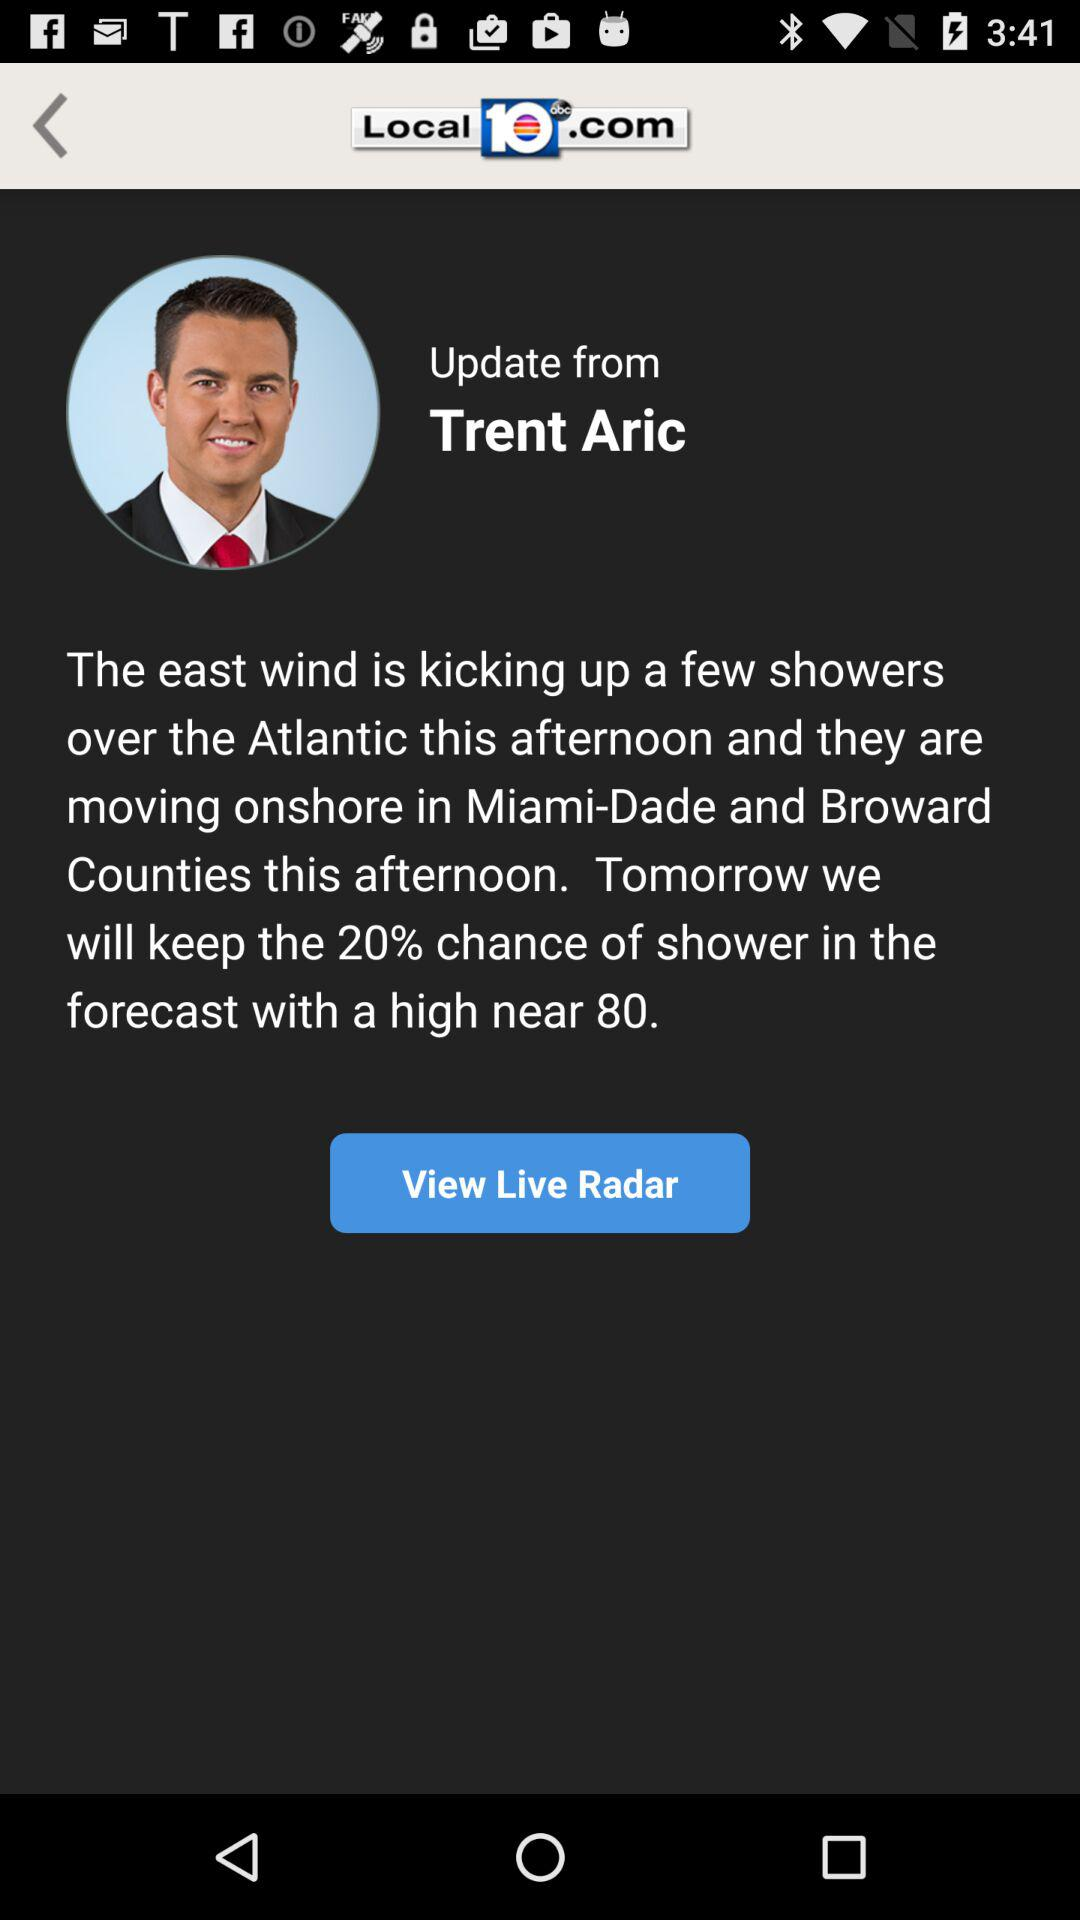Where does the east wind kick up showers? The east wind kicks up showers over the Atlantic. 